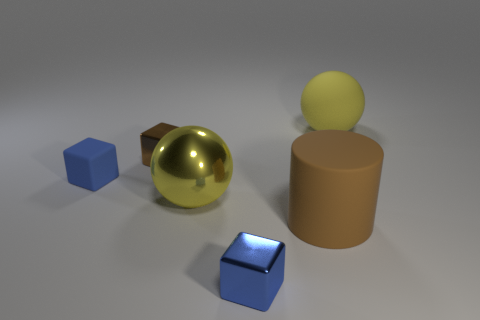Subtract all blue matte blocks. How many blocks are left? 2 Subtract all purple balls. How many blue blocks are left? 2 Add 1 metallic spheres. How many objects exist? 7 Add 1 big yellow things. How many big yellow things exist? 3 Subtract 1 brown blocks. How many objects are left? 5 Subtract all balls. How many objects are left? 4 Subtract all red cubes. Subtract all yellow balls. How many cubes are left? 3 Subtract all tiny red blocks. Subtract all cubes. How many objects are left? 3 Add 1 big metal objects. How many big metal objects are left? 2 